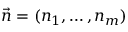Convert formula to latex. <formula><loc_0><loc_0><loc_500><loc_500>\vec { n } = ( n _ { 1 } , \dots , n _ { m } )</formula> 